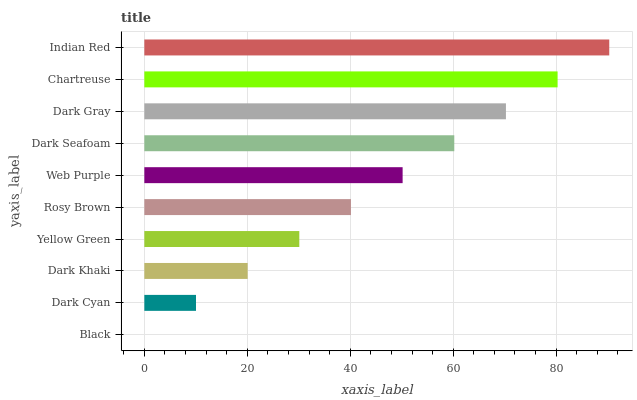Is Black the minimum?
Answer yes or no. Yes. Is Indian Red the maximum?
Answer yes or no. Yes. Is Dark Cyan the minimum?
Answer yes or no. No. Is Dark Cyan the maximum?
Answer yes or no. No. Is Dark Cyan greater than Black?
Answer yes or no. Yes. Is Black less than Dark Cyan?
Answer yes or no. Yes. Is Black greater than Dark Cyan?
Answer yes or no. No. Is Dark Cyan less than Black?
Answer yes or no. No. Is Web Purple the high median?
Answer yes or no. Yes. Is Rosy Brown the low median?
Answer yes or no. Yes. Is Dark Seafoam the high median?
Answer yes or no. No. Is Dark Cyan the low median?
Answer yes or no. No. 